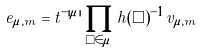<formula> <loc_0><loc_0><loc_500><loc_500>e _ { \mu , m } = t ^ { - | \mu | } \prod _ { \Box \in \mu } h ( \Box ) ^ { - 1 } v _ { \mu , m }</formula> 